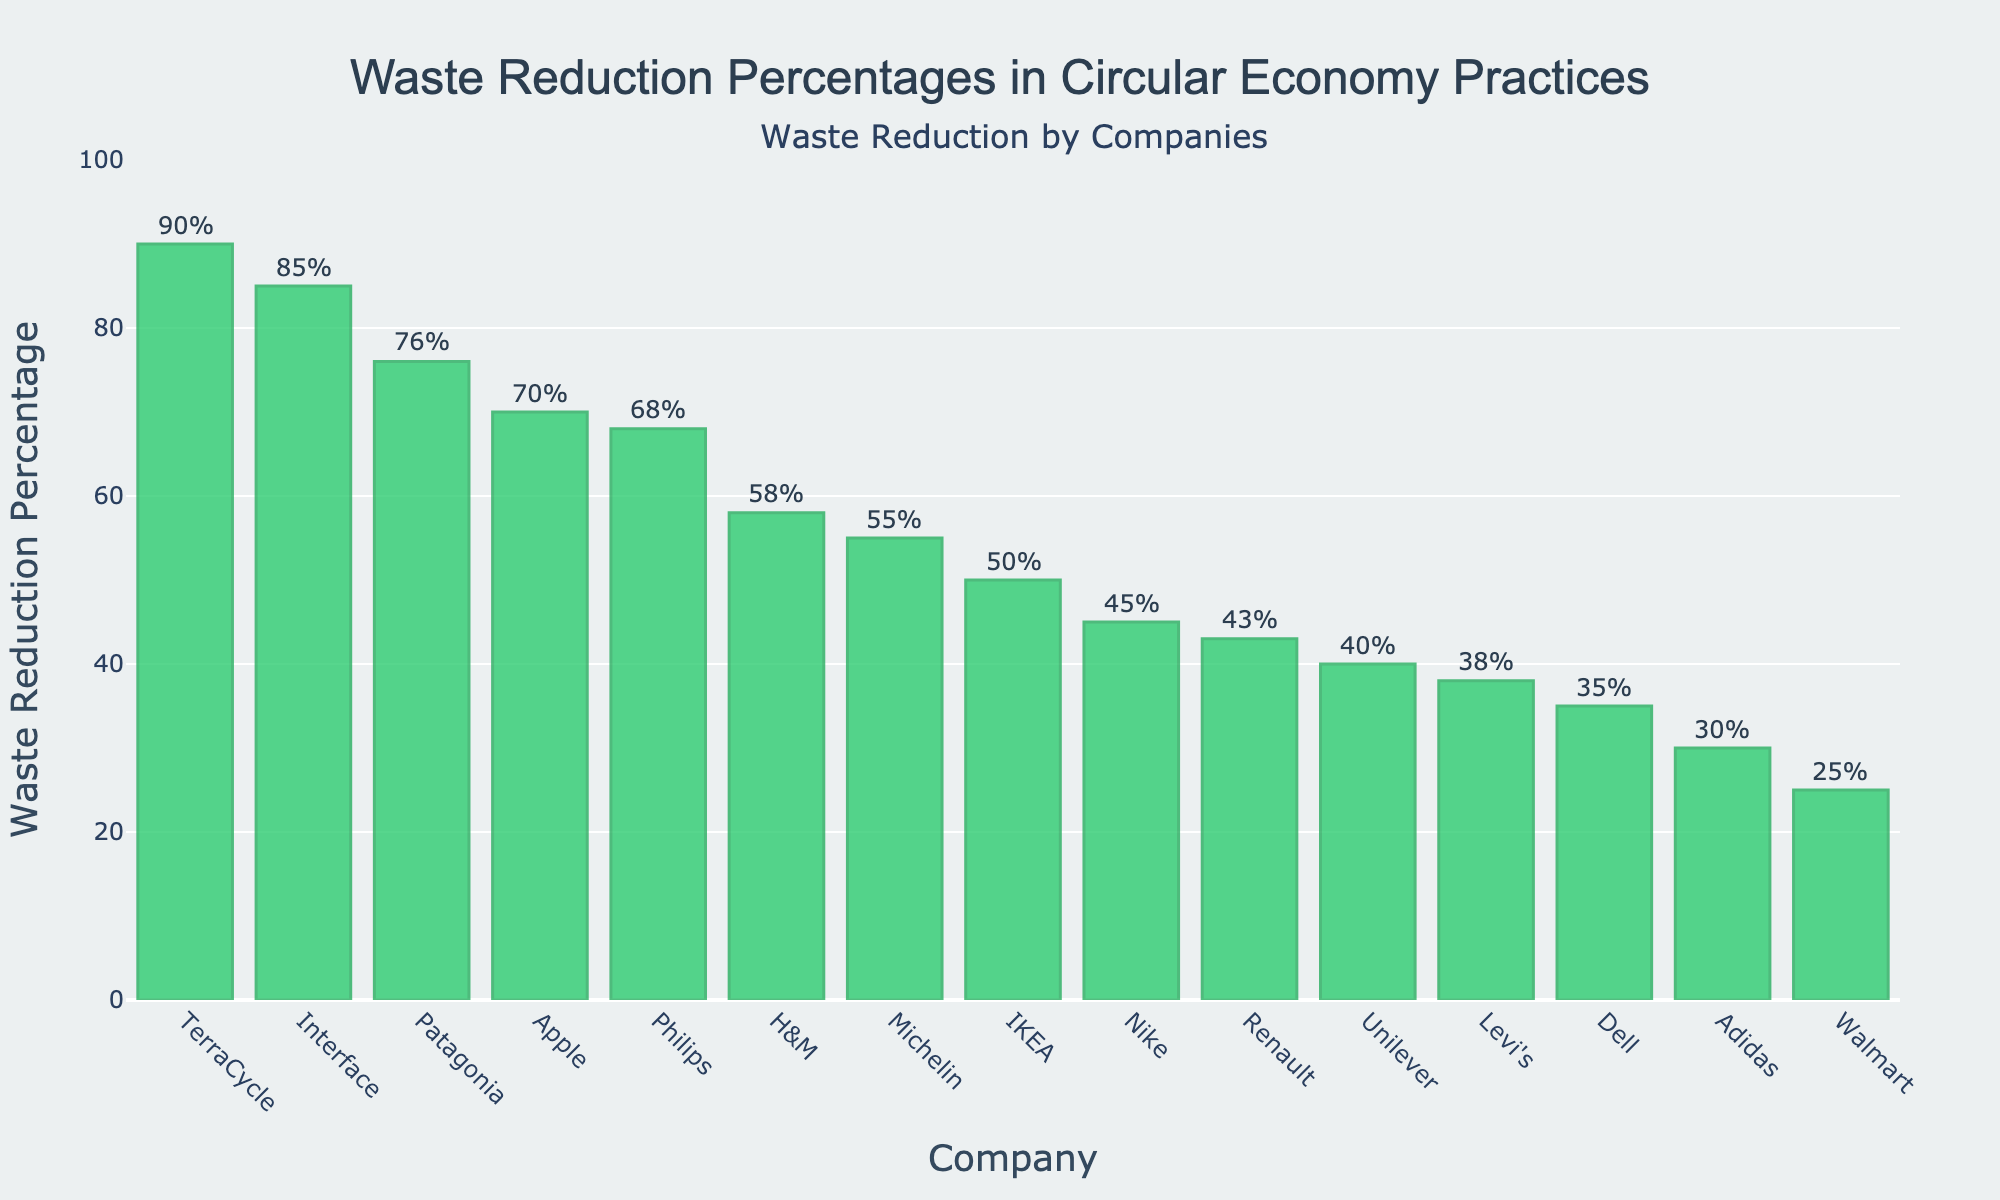What's the highest waste reduction percentage achieved by a company? Identify the tallest bar in the figure. The company with the highest waste reduction percentage is TerraCycle, with a value of 90%.
Answer: 90% What is the difference in waste reduction percentage between Interface and Walmart? Find the waste reduction percentages for Interface and Walmart from the heights of their respective bars: 85% for Interface and 25% for Walmart. Subtract the smaller value from the larger value: 85% - 25% = 60%.
Answer: 60% Which company has a higher waste reduction percentage, Apple or IKEA? Compare the heights of the bars for Apple and IKEA. Apple's bar shows 70%, while IKEA's bar shows 50%. Apple has a higher percentage.
Answer: Apple What is the total waste reduction percentage for Patagonia, Unilever, and Nike combined? Sum the waste reduction percentages shown for Patagonia (76%), Unilever (40%), and Nike (45%). 76% + 40% + 45% = 161%.
Answer: 161% What is the average waste reduction percentage of H&M, Adidas, and Michelin? Sum the waste reduction percentages for H&M (58%), Adidas (30%), and Michelin (55%), then divide by the number of companies (3). (58% + 30% + 55%) / 3 = 47.67%.
Answer: 47.67% Which company achieved a waste reduction percentage closest to 50%? Look for the bar that is nearest to the 50% mark on the y-axis. IKEA has a waste reduction percentage of exactly 50%.
Answer: IKEA What is the median waste reduction percentage across all companies? Arrange the waste reduction percentages in ascending order and find the middle value. The sorted values are: 25%, 30%, 35%, 38%, 40%, 43%, 45%, 50%, 55%, 58%, 68%, 70%, 76%, 85%, 90%. The middle value (8th in a list of 15) is 50%.
Answer: 50% How many companies have a waste reduction percentage above 60%? Count the bars that exceed the 60% mark on the y-axis. The companies are Patagonia (76%), Interface (85%), Philips (68%), Apple (70%), and TerraCycle (90%). There are 5 companies.
Answer: 5 